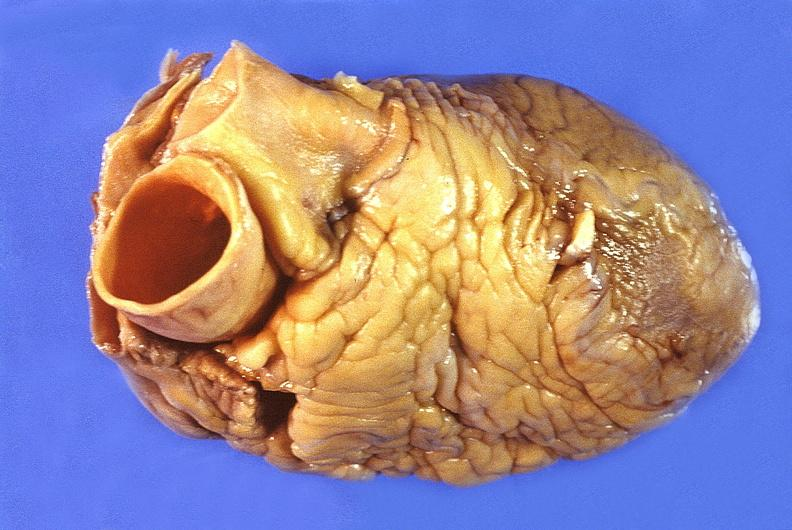does this image show normal cardiovascular?
Answer the question using a single word or phrase. Yes 